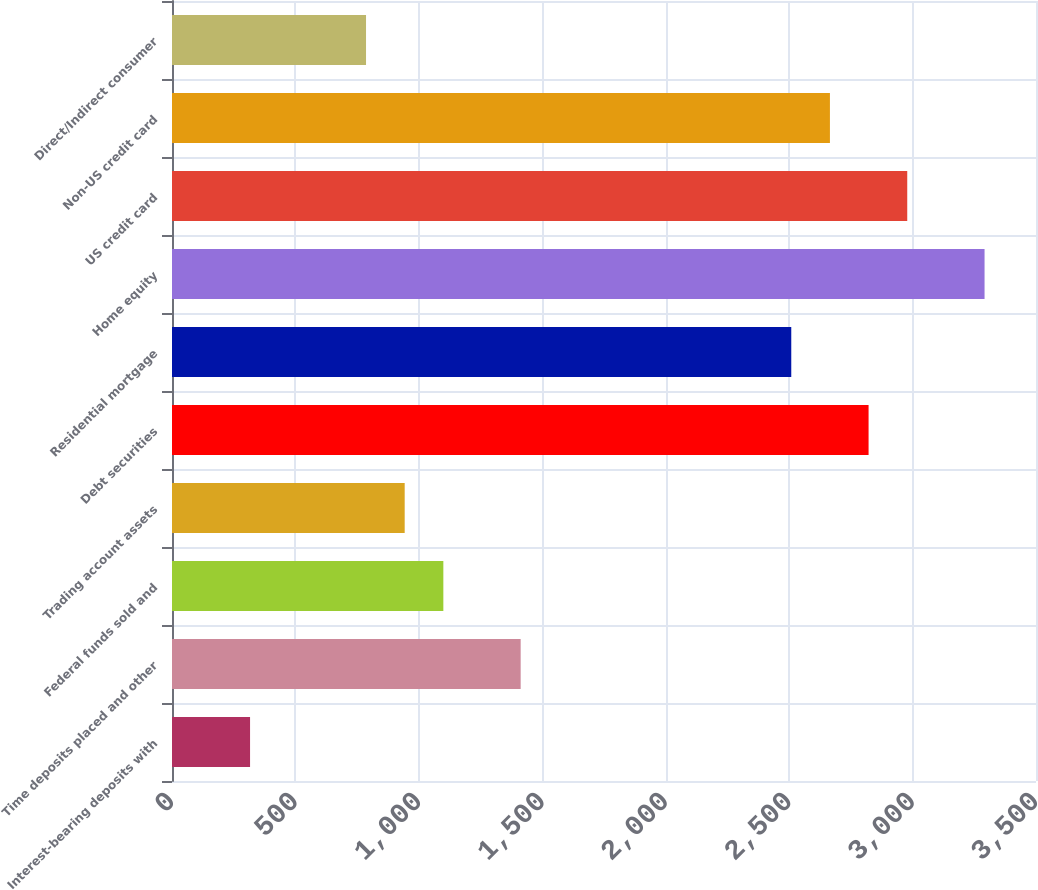Convert chart. <chart><loc_0><loc_0><loc_500><loc_500><bar_chart><fcel>Interest-bearing deposits with<fcel>Time deposits placed and other<fcel>Federal funds sold and<fcel>Trading account assets<fcel>Debt securities<fcel>Residential mortgage<fcel>Home equity<fcel>US credit card<fcel>Non-US credit card<fcel>Direct/Indirect consumer<nl><fcel>316.2<fcel>1412.4<fcel>1099.2<fcel>942.6<fcel>2821.8<fcel>2508.6<fcel>3291.6<fcel>2978.4<fcel>2665.2<fcel>786<nl></chart> 